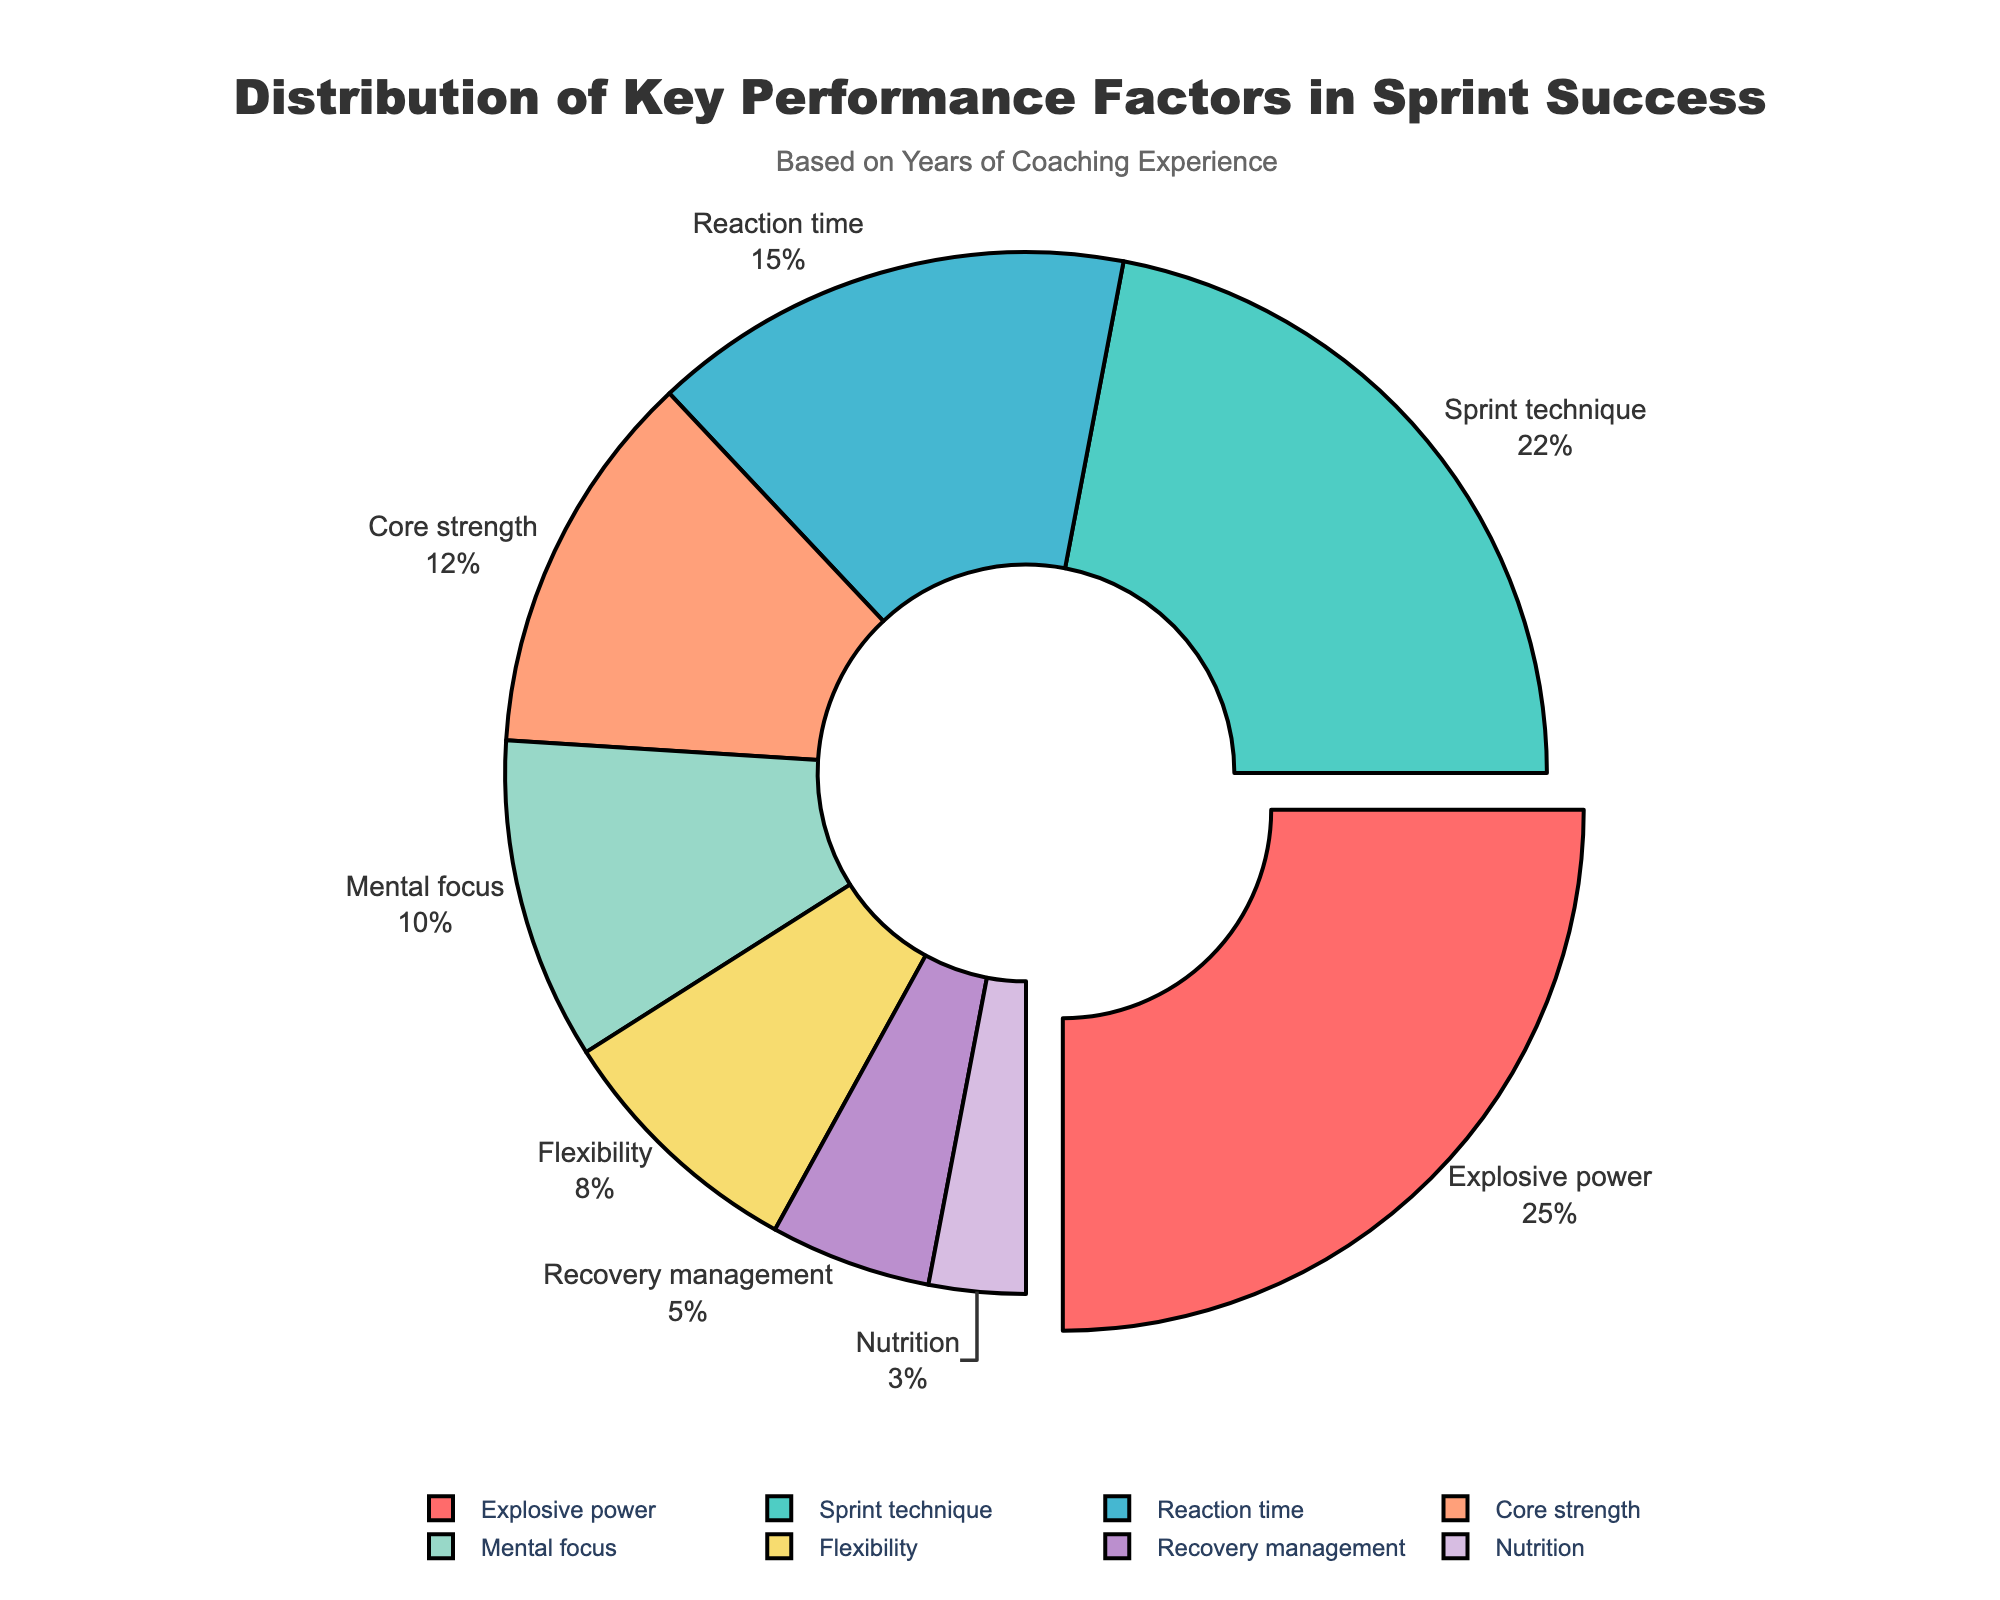What percentage of sprint success is attributed to explosive power? Explosive power contributes 25% to sprint success as shown in the figure.
Answer: 25% Which factor contributes the least to sprint success? Nutrition is the factor with the smallest percentage, contributing 3% to sprint success.
Answer: Nutrition Which categories together account for more than half of the sprint success? Adding the percentages: Explosive power (25%) + Sprint technique (22%) + Reaction time (15%) = 62%, accounts for more than half of the total.
Answer: Explosive power, Sprint technique, Reaction time How much more does explosive power contribute than recovery management? Explosive power contributes 25%, while recovery management contributes 5%. The difference is 25% - 5% = 20%.
Answer: 20% What is the visual characteristic that identifies the factor contributing the most to sprint success? The factor with the highest contribution, explosive power, is slightly pulled out from the pie chart, making it visually distinct.
Answer: Pulled out section What is the sum of the percentages of reaction time, core strength, and mental focus? Reaction time (15%) + Core strength (12%) + Mental focus (10%) = 37%.
Answer: 37% Which factors combined contribute equally to the total contribution of sprint technique? Mental focus (10%) + Flexibility (8%) + Nutrition (3%) = 10% + 8% + 3% = 21%, approximately close to sprint technique's 22%.
Answer: Mental focus, Flexibility, Nutrition Is the contribution of flexibility greater or less than mental focus? Flexibility contributes 8%, whereas mental focus contributes 10%. Therefore, flexibility contributes less.
Answer: Less If core strength were increased by 3 percentage points, how much would it then contribute? Core strength's current contribution is 12%. Increasing it by 3 percentage points results in 12% + 3% = 15%.
Answer: 15% Which factor, if removed, would result in the smallest change in the overall distribution? Nutrition has the smallest contribution at 3%, so its removal would result in the smallest change.
Answer: Nutrition 